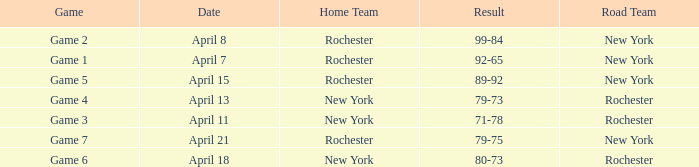Which Result has a Home Team of rochester, and a Game of game 5? 89-92. 